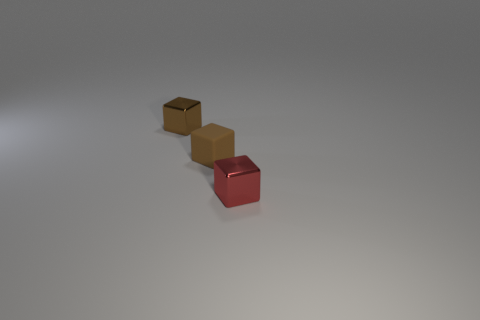Are there fewer small brown metal objects than small yellow shiny blocks?
Provide a short and direct response. No. How many cubes are the same color as the tiny rubber object?
Provide a short and direct response. 1. Is the color of the small metallic block that is to the left of the brown rubber block the same as the tiny rubber block?
Provide a short and direct response. Yes. There is a small brown object that is behind the small brown rubber thing; what shape is it?
Provide a succinct answer. Cube. Are there any tiny red blocks that are in front of the brown thing behind the matte block?
Your answer should be compact. Yes. How many tiny brown blocks have the same material as the red cube?
Your response must be concise. 1. How many tiny brown matte objects are to the right of the brown rubber object?
Keep it short and to the point. 0. Is the number of brown matte objects greater than the number of tiny metal objects?
Make the answer very short. No. There is a cube that is both behind the small red metal object and in front of the tiny brown metallic cube; what is its size?
Provide a short and direct response. Small. What is the material of the small object that is on the right side of the brown matte block left of the tiny cube in front of the matte block?
Your answer should be very brief. Metal. 